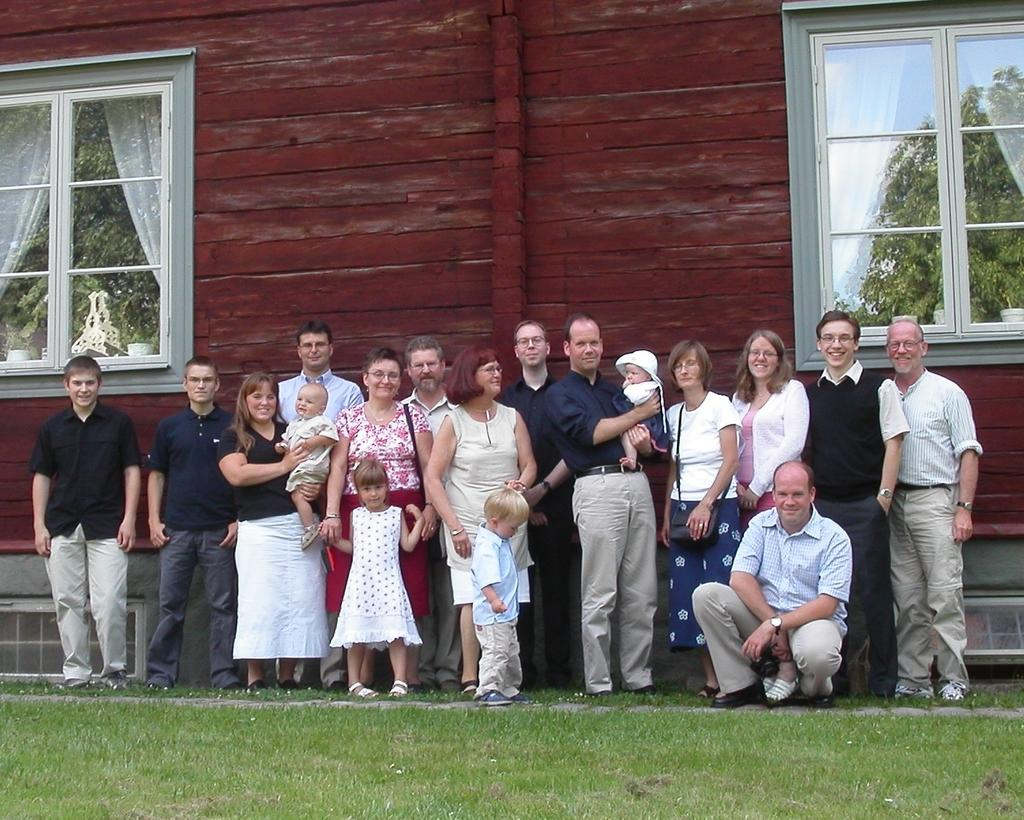What is the main subject of the image? The main subject of the image is a group of persons in the center of the image. Where are the persons located in the image? The group of persons is on the grass. What can be seen in the background of the image? There is a building in the background of the image. What type of surface is visible at the bottom of the image? Grass is present at the bottom of the image. How many children are wearing collars in the image? There are no children or collars present in the image. 